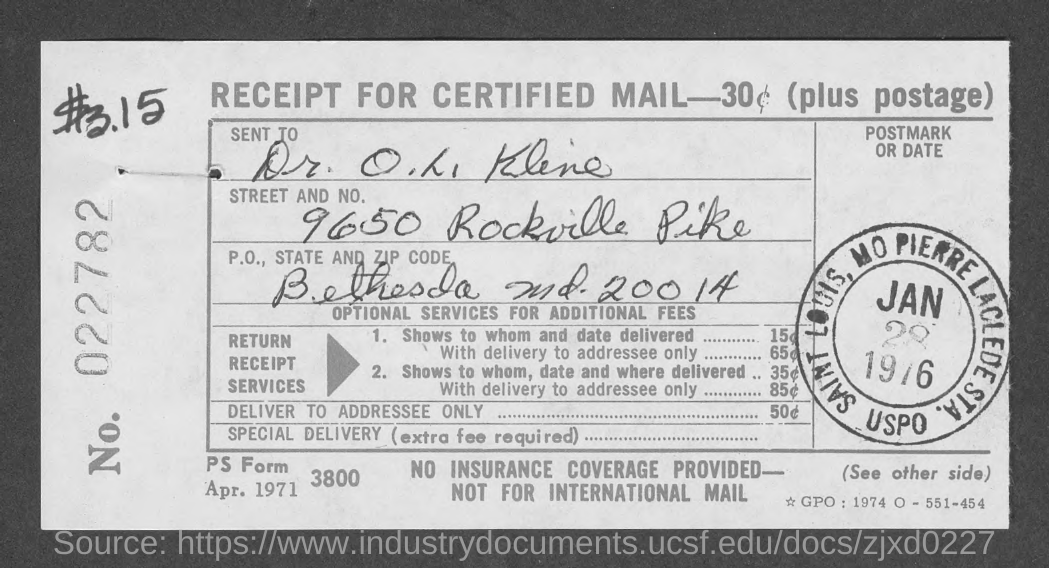To whom, the mail is sent?
Your answer should be compact. Dr. O. L. Kline. What is the P.O., State and Zip code given in the receipt?
Your answer should be very brief. Bethesda md. 20014. 